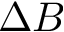<formula> <loc_0><loc_0><loc_500><loc_500>\Delta B</formula> 